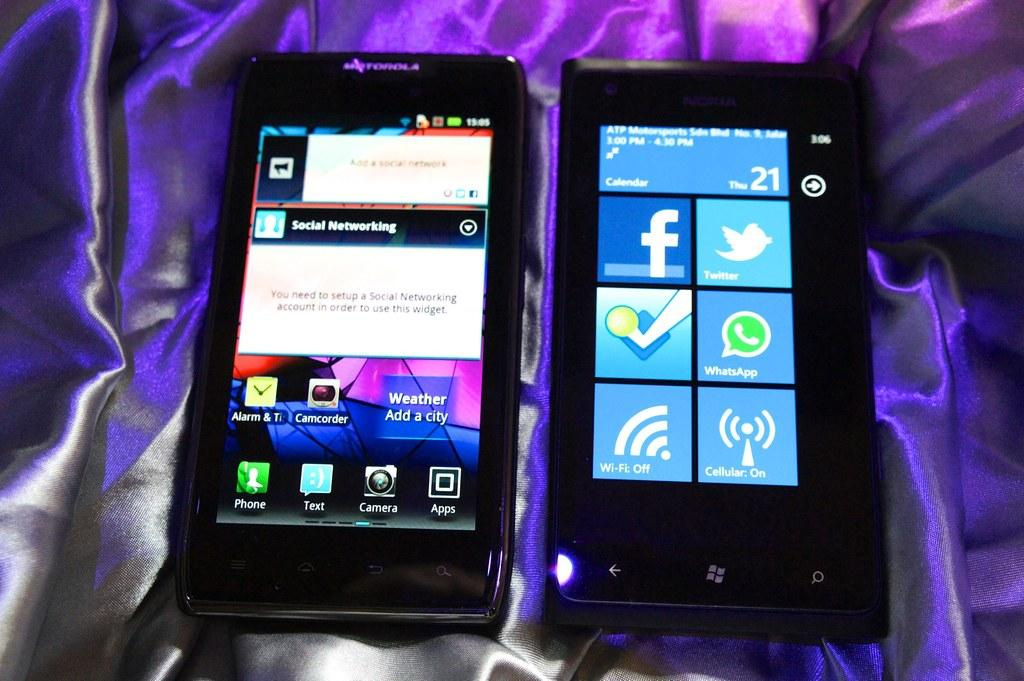<image>
Write a terse but informative summary of the picture. Two phone ssit next to each other with one saying Social networking. 